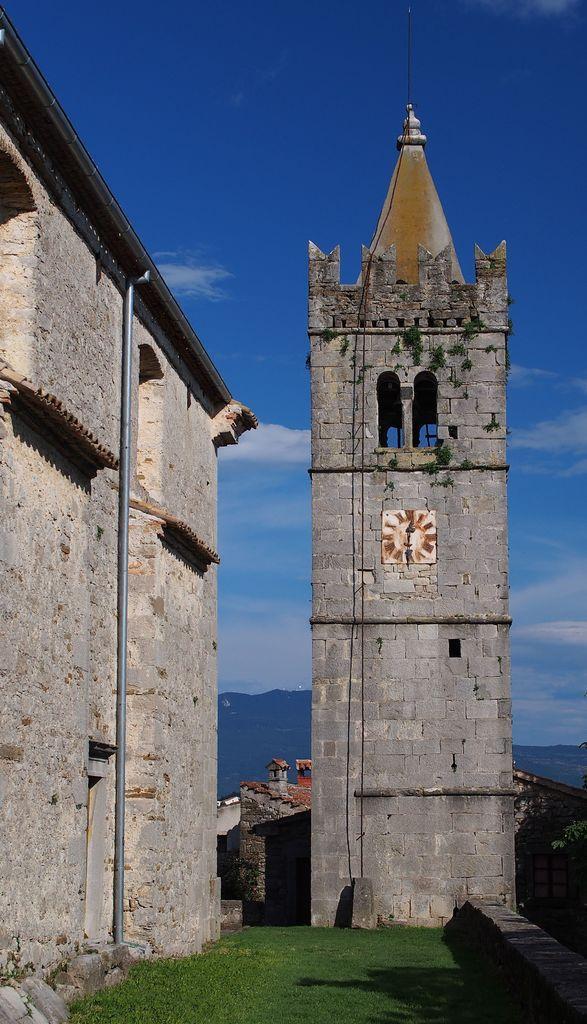Please provide a concise description of this image. In the image there is a castle in the front on the grassland and in the back it seems to be hill and above its sky with clouds. 